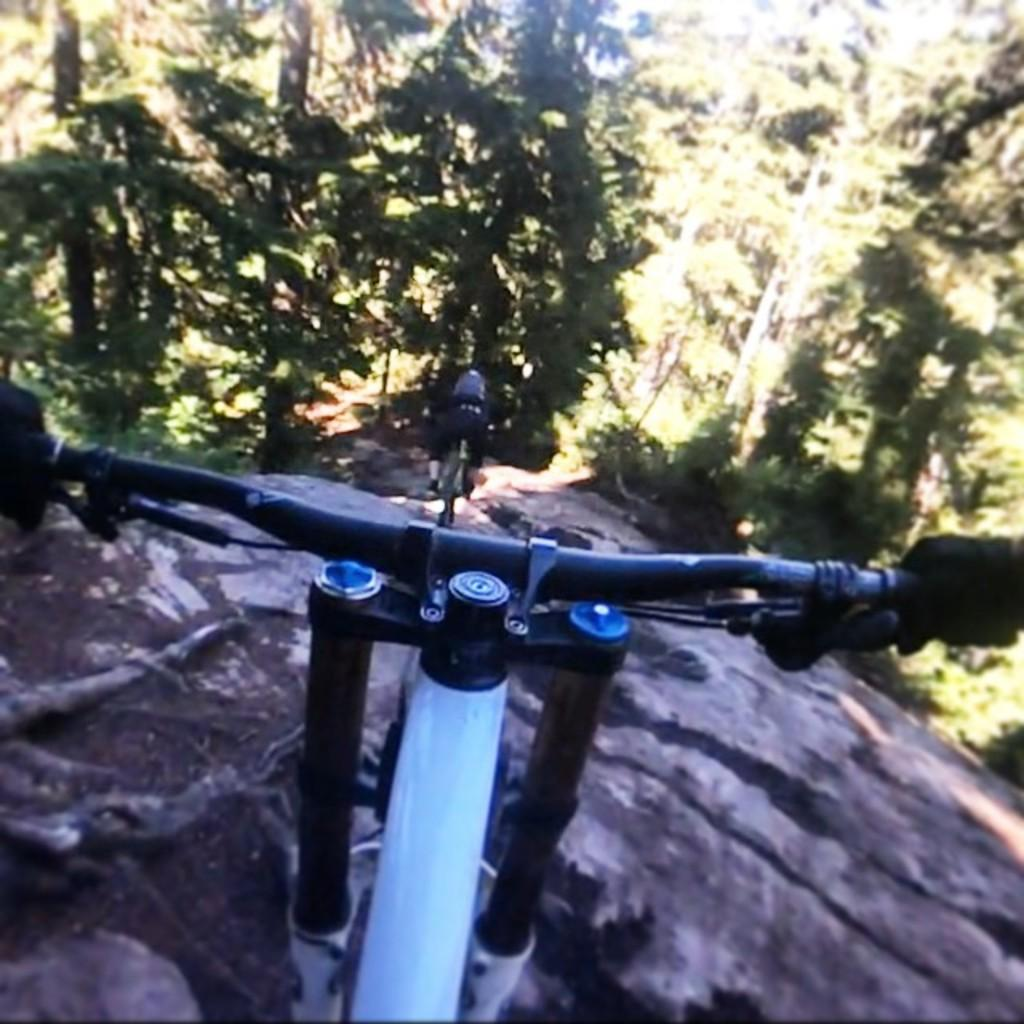What object is partially visible at the bottom of the image? There is a portion of a bicycle at the bottom of the image. Where is the bicycle located? The bicycle is on a mountain. What type of vegetation can be seen at the top of the image? There are trees visible at the top of the image. What is the bicycle's tendency to lock itself when not in use? There is no information about the bicycle's locking mechanism in the image, so we cannot determine its tendency to lock itself. 